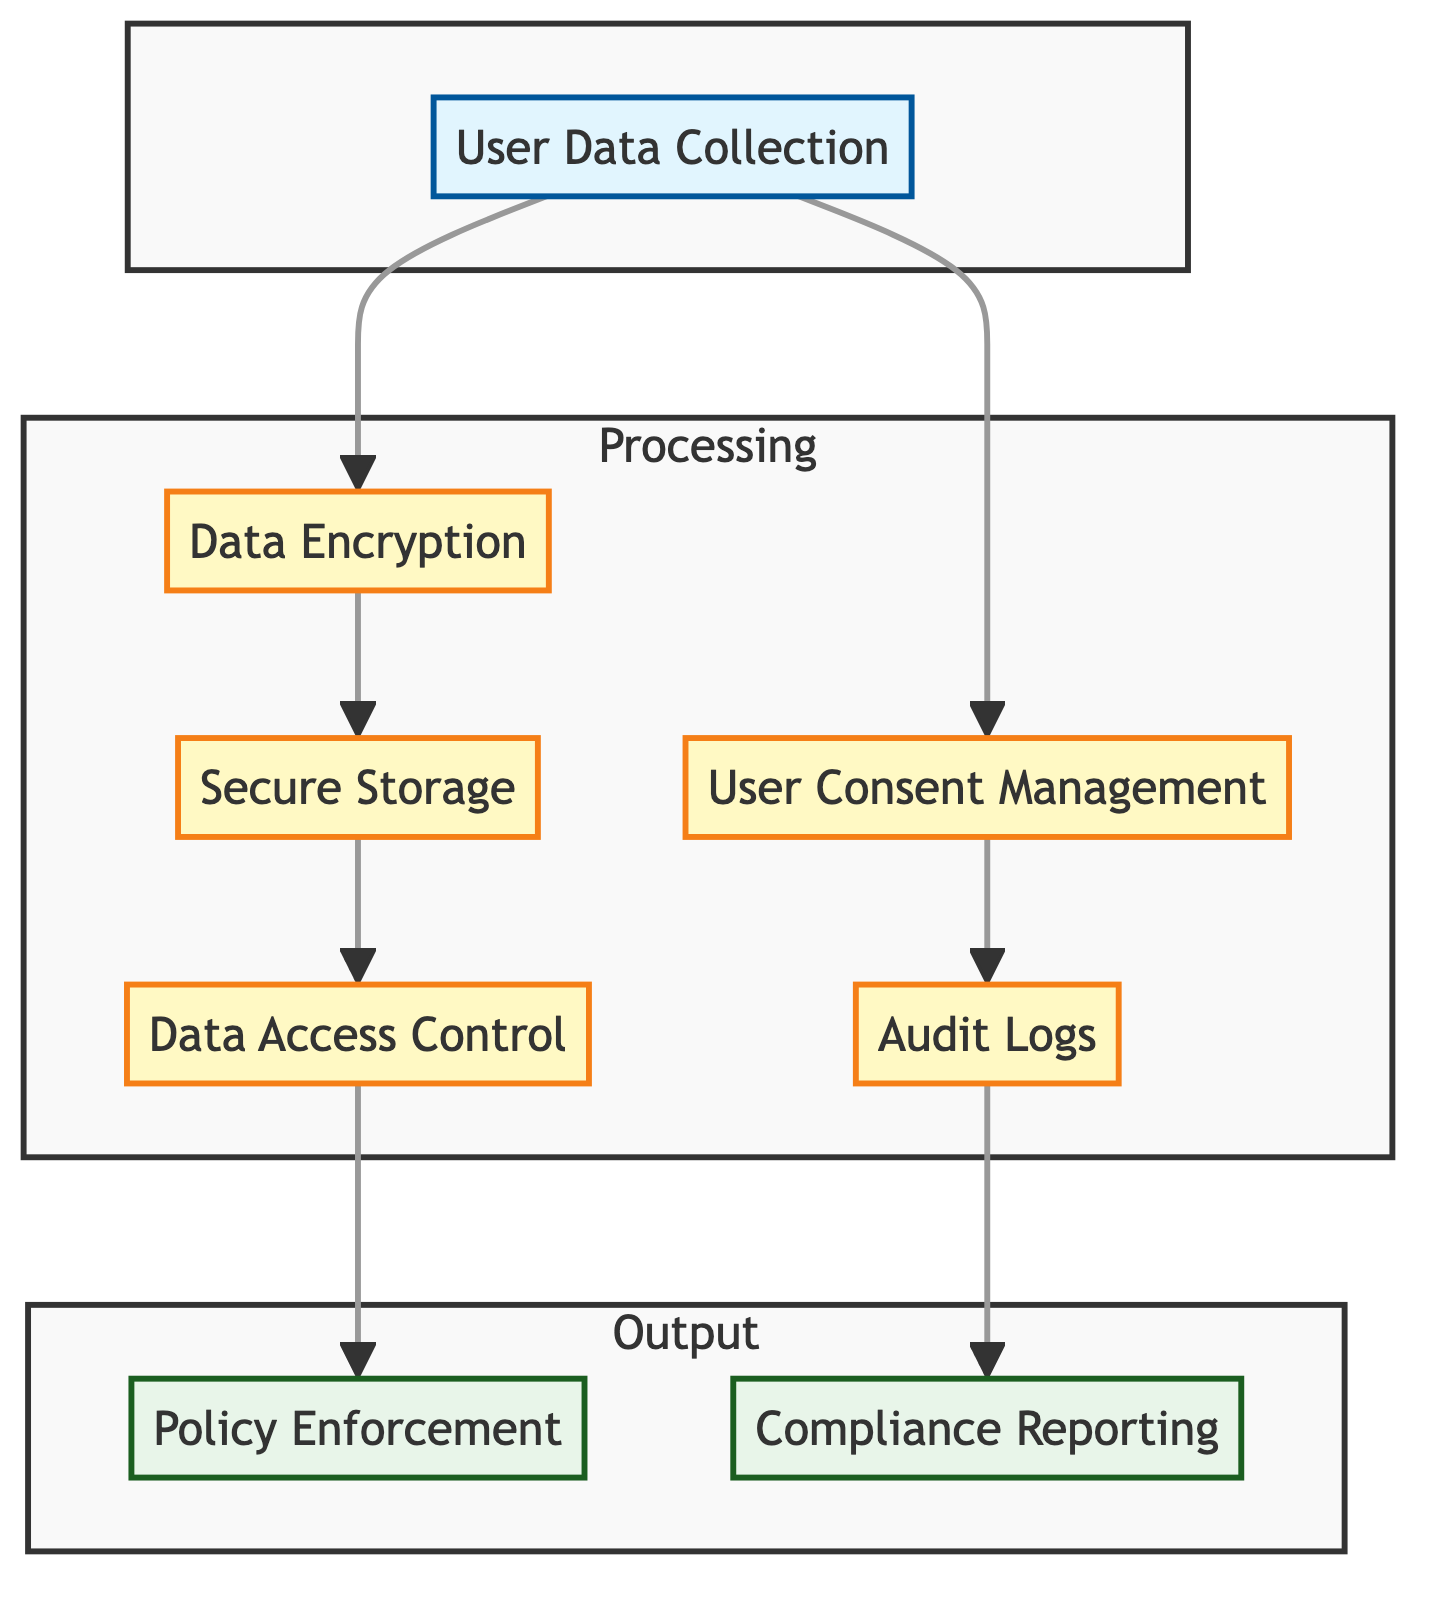What is the first block in the diagram? The first block in the diagram is labeled "User Data Collection" and it serves as the starting point for the data flow.
Answer: User Data Collection How many output connections does the "User Data Collection" block have? The "User Data Collection" block outputs to two other blocks: "Data Encryption" and "User Consent Management." Therefore, it has two output connections.
Answer: 2 What type of data does "User Data Collection" handle? The "User Data Collection" block handles several types of user data including Personal Identifiable Information, resumes, and cover letters. This information can be viewed in the details section of the block.
Answer: Personal Identifiable Information, resumes, cover letters Which block follows "Data Encryption"? The "Data Encryption" block leads to the "Secure Storage" block as indicated by the directional arrow connecting them in the diagram.
Answer: Secure Storage What are the compliance requirements associated with the "User Consent Management" block? The "User Consent Management" block has compliance requirements listed as GDPR Article 7 and EEOC Recordkeeping. These requirements ensure that the necessary legal standards are met in managing user consent.
Answer: GDPR Article 7, EEOC Recordkeeping What types of logs does the "Audit Logs" block consist of? The "Audit Logs" block consists of Access Logs and Consent Logs, which are identified in the details of the block's information.
Answer: Access Logs, Consent Logs What is the output of the "Data Access Control" block? The "Data Access Control" block outputs to two blocks: "Data Monitoring" and "Policy Enforcement," indicating its role in controlling access and enforcing policies.
Answer: Data Monitoring, Policy Enforcement What is the relationship between "Secure Storage" and "Data Access Control"? The "Secure Storage" block serves as an input to the "Data Access Control" block, meaning that data must be securely stored before access control measures are applied.
Answer: Secure Storage is an input to Data Access Control How often is "Compliance Reporting" generated as per the diagram? The "Compliance Reporting" block indicates that reports are generated either quarterly or annually, as stated in the details section of the block.
Answer: Quarterly, Annually 